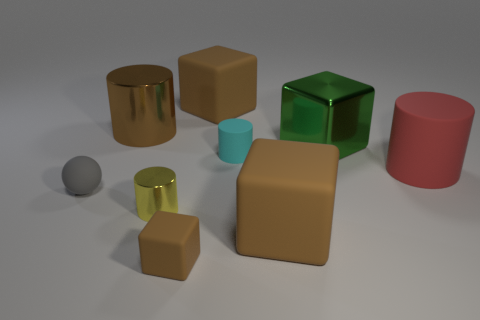Do the small rubber block and the big shiny cylinder have the same color?
Your answer should be compact. Yes. Do the tiny object that is on the right side of the small brown block and the brown object that is left of the small block have the same shape?
Your answer should be very brief. Yes. What number of other things are the same size as the yellow thing?
Your answer should be compact. 3. What size is the green shiny cube?
Keep it short and to the point. Large. Does the thing that is behind the brown shiny cylinder have the same material as the yellow object?
Keep it short and to the point. No. The other small thing that is the same shape as the tiny metallic object is what color?
Ensure brevity in your answer.  Cyan. Does the big block in front of the large red rubber object have the same color as the big metallic cylinder?
Make the answer very short. Yes. There is a gray rubber object; are there any cylinders behind it?
Offer a very short reply. Yes. The object that is both left of the tiny metal object and on the right side of the gray rubber object is what color?
Offer a terse response. Brown. The large metallic thing that is the same color as the tiny cube is what shape?
Offer a terse response. Cylinder. 